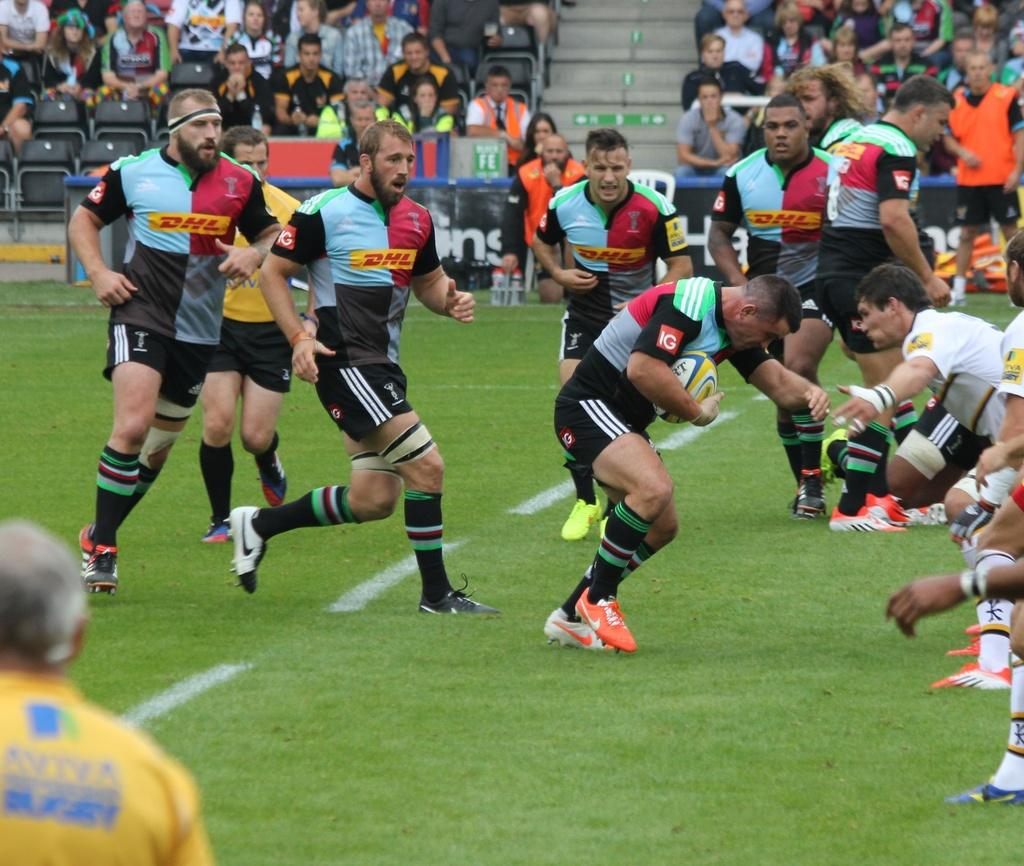What activity is the group of people in the image engaged in? The group of people in the image is playing a game. Can you describe the setting of the image? In the background, there is a group of people sitting on chairs, watching the game. What are the people in the background doing? The people in the background are watching the game being played by the group of people in the image. What type of car can be seen driving on the ground in the image? There is no car or ground visible in the image; it features a group of people playing a game and a background with people sitting on chairs. 